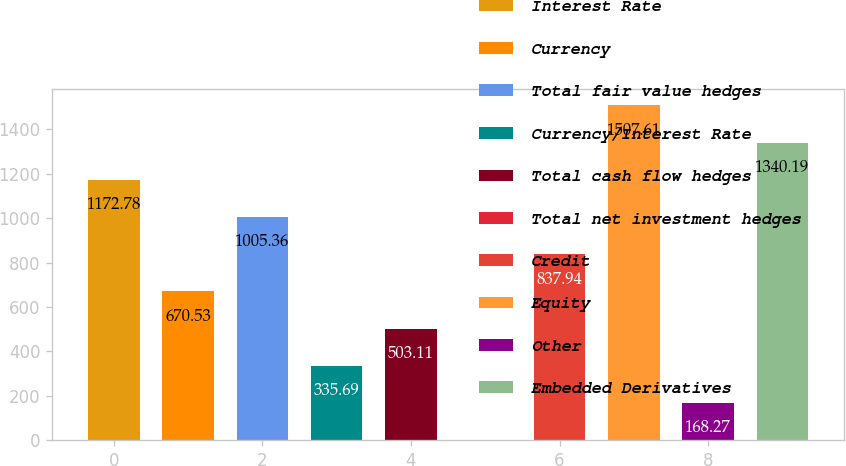<chart> <loc_0><loc_0><loc_500><loc_500><bar_chart><fcel>Interest Rate<fcel>Currency<fcel>Total fair value hedges<fcel>Currency/Interest Rate<fcel>Total cash flow hedges<fcel>Total net investment hedges<fcel>Credit<fcel>Equity<fcel>Other<fcel>Embedded Derivatives<nl><fcel>1172.78<fcel>670.53<fcel>1005.36<fcel>335.69<fcel>503.11<fcel>0.85<fcel>837.94<fcel>1507.61<fcel>168.27<fcel>1340.19<nl></chart> 